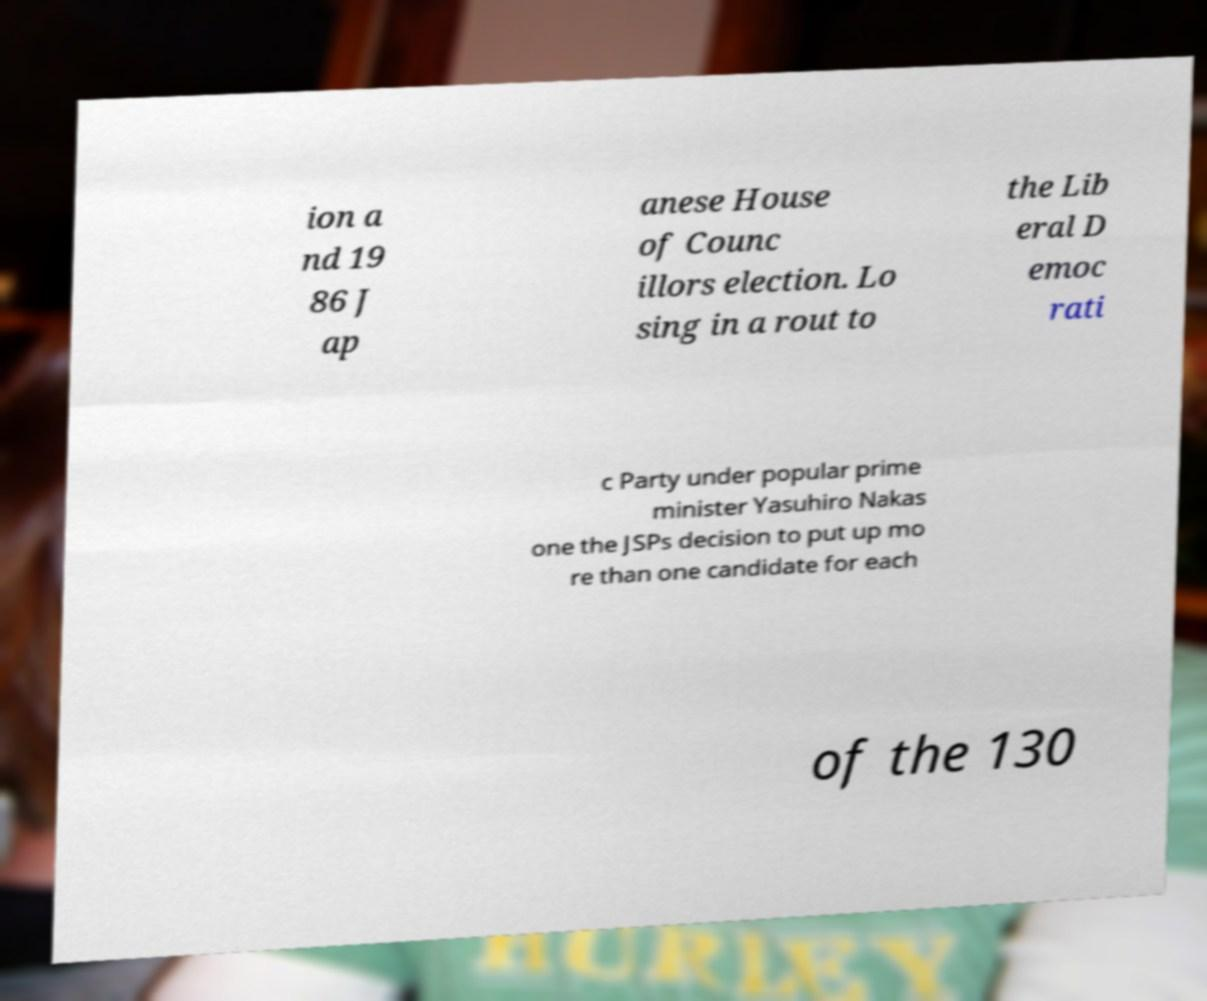Can you accurately transcribe the text from the provided image for me? ion a nd 19 86 J ap anese House of Counc illors election. Lo sing in a rout to the Lib eral D emoc rati c Party under popular prime minister Yasuhiro Nakas one the JSPs decision to put up mo re than one candidate for each of the 130 